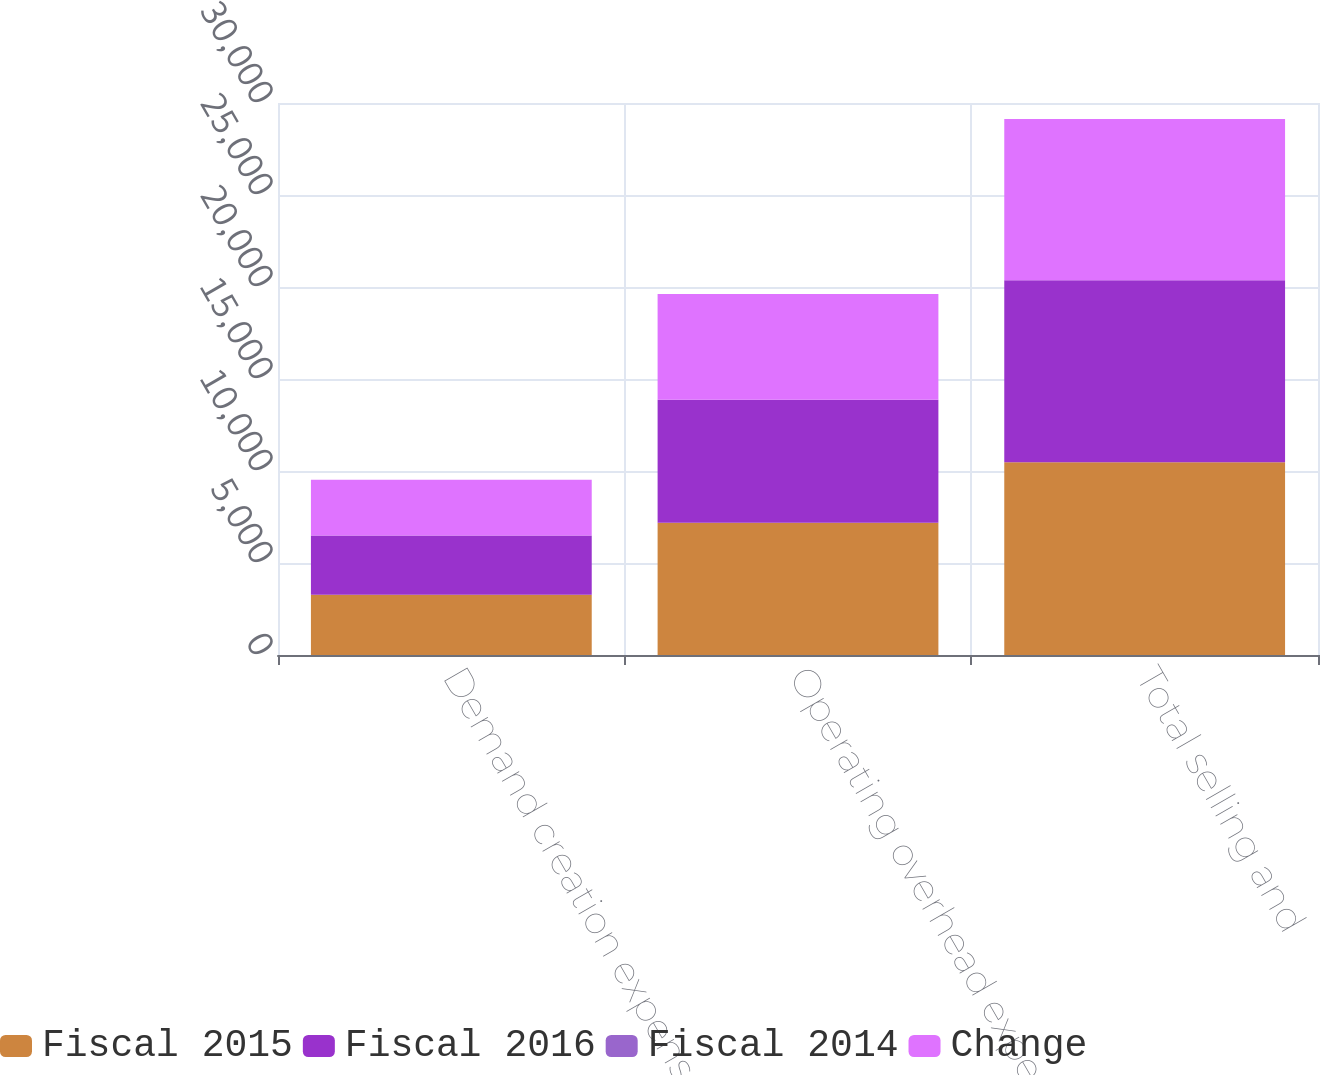Convert chart to OTSL. <chart><loc_0><loc_0><loc_500><loc_500><stacked_bar_chart><ecel><fcel>Demand creation expense (1)<fcel>Operating overhead expense<fcel>Total selling and<nl><fcel>Fiscal 2015<fcel>3278<fcel>7191<fcel>10469<nl><fcel>Fiscal 2016<fcel>3213<fcel>6679<fcel>9892<nl><fcel>Fiscal 2014<fcel>2<fcel>8<fcel>6<nl><fcel>Change<fcel>3031<fcel>5735<fcel>8766<nl></chart> 